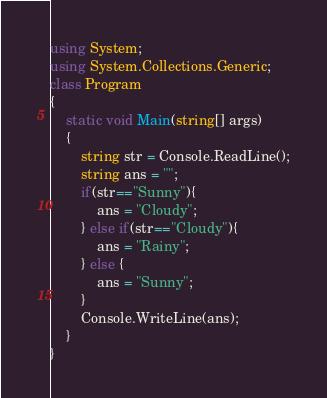<code> <loc_0><loc_0><loc_500><loc_500><_C#_>using System;
using System.Collections.Generic;
class Program
{
	static void Main(string[] args)
	{
		string str = Console.ReadLine();
		string ans = "";
		if(str=="Sunny"){
			ans = "Cloudy";
		} else if(str=="Cloudy"){
			ans = "Rainy";
		} else {
			ans = "Sunny";
		}
		Console.WriteLine(ans);
	}
}</code> 